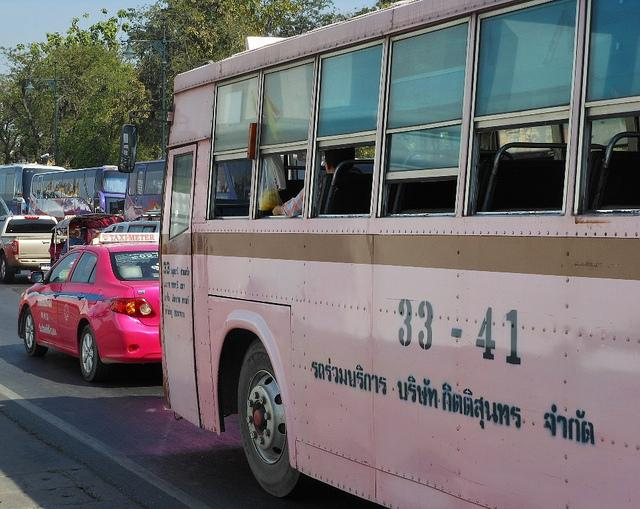What continent is this road located at? asia 